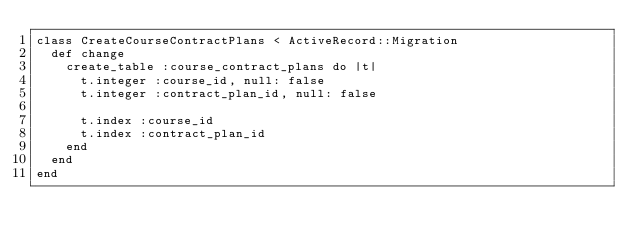<code> <loc_0><loc_0><loc_500><loc_500><_Ruby_>class CreateCourseContractPlans < ActiveRecord::Migration
  def change
    create_table :course_contract_plans do |t|
      t.integer :course_id, null: false
      t.integer :contract_plan_id, null: false

      t.index :course_id
      t.index :contract_plan_id
    end
  end
end
</code> 